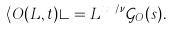Convert formula to latex. <formula><loc_0><loc_0><loc_500><loc_500>\langle O ( L , t ) \rangle = L ^ { x _ { O } / \nu } \mathcal { G } _ { O } ( s ) .</formula> 